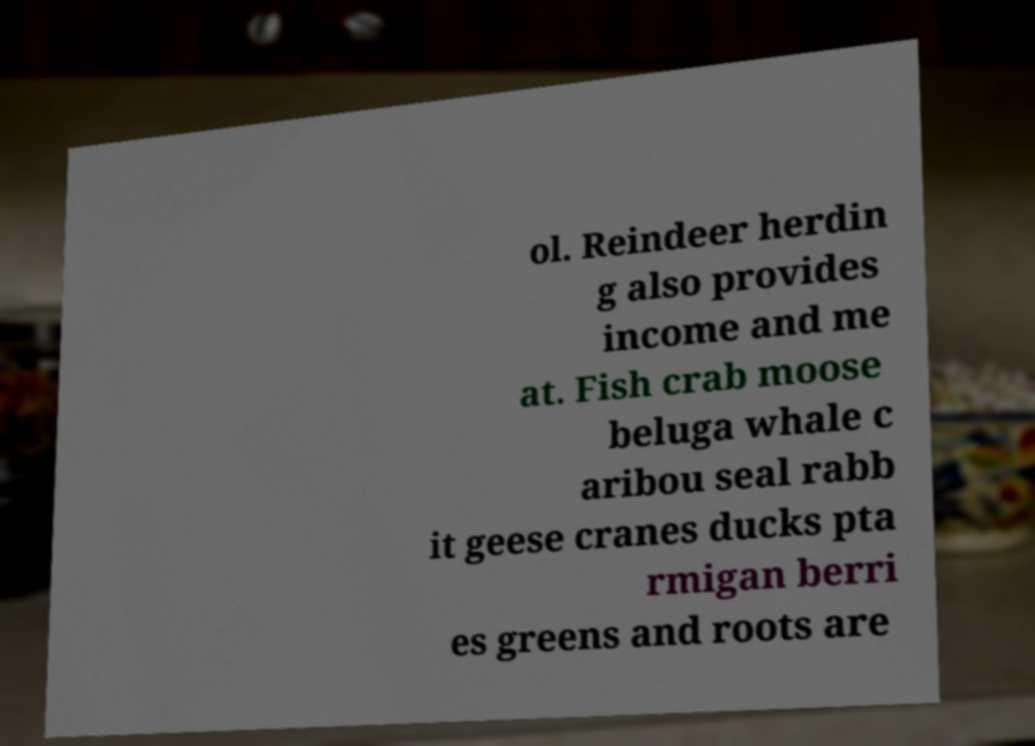What messages or text are displayed in this image? I need them in a readable, typed format. ol. Reindeer herdin g also provides income and me at. Fish crab moose beluga whale c aribou seal rabb it geese cranes ducks pta rmigan berri es greens and roots are 